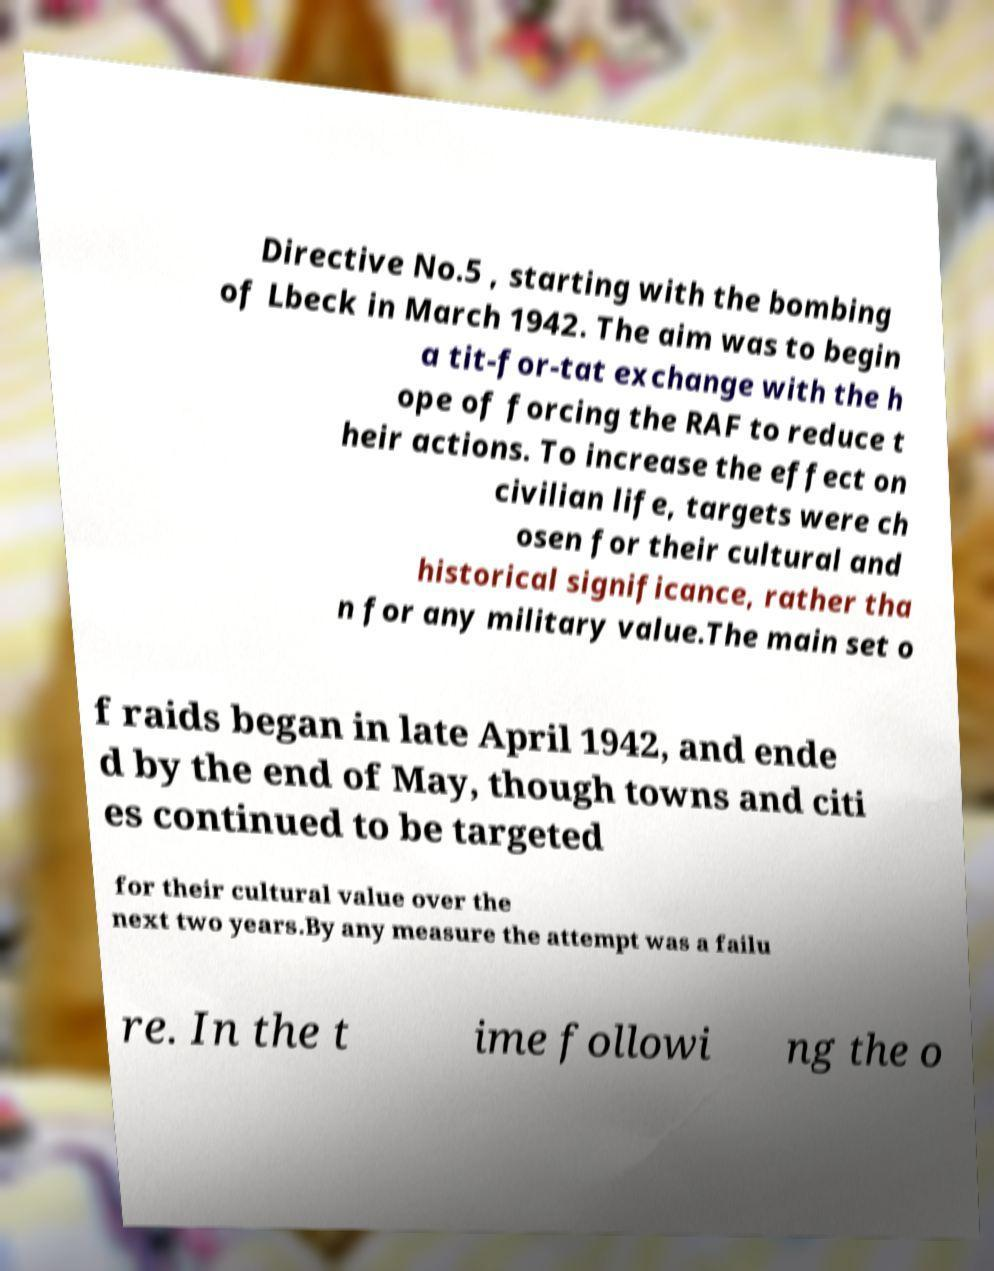Please identify and transcribe the text found in this image. Directive No.5 , starting with the bombing of Lbeck in March 1942. The aim was to begin a tit-for-tat exchange with the h ope of forcing the RAF to reduce t heir actions. To increase the effect on civilian life, targets were ch osen for their cultural and historical significance, rather tha n for any military value.The main set o f raids began in late April 1942, and ende d by the end of May, though towns and citi es continued to be targeted for their cultural value over the next two years.By any measure the attempt was a failu re. In the t ime followi ng the o 